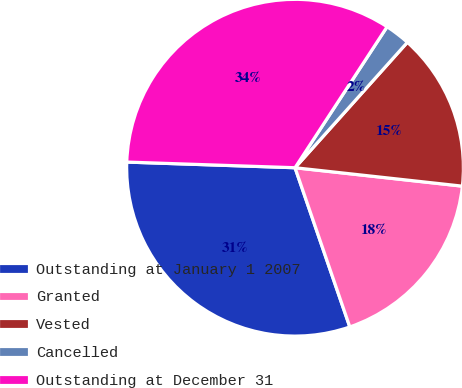Convert chart. <chart><loc_0><loc_0><loc_500><loc_500><pie_chart><fcel>Outstanding at January 1 2007<fcel>Granted<fcel>Vested<fcel>Cancelled<fcel>Outstanding at December 31<nl><fcel>30.81%<fcel>17.98%<fcel>15.12%<fcel>2.42%<fcel>33.67%<nl></chart> 